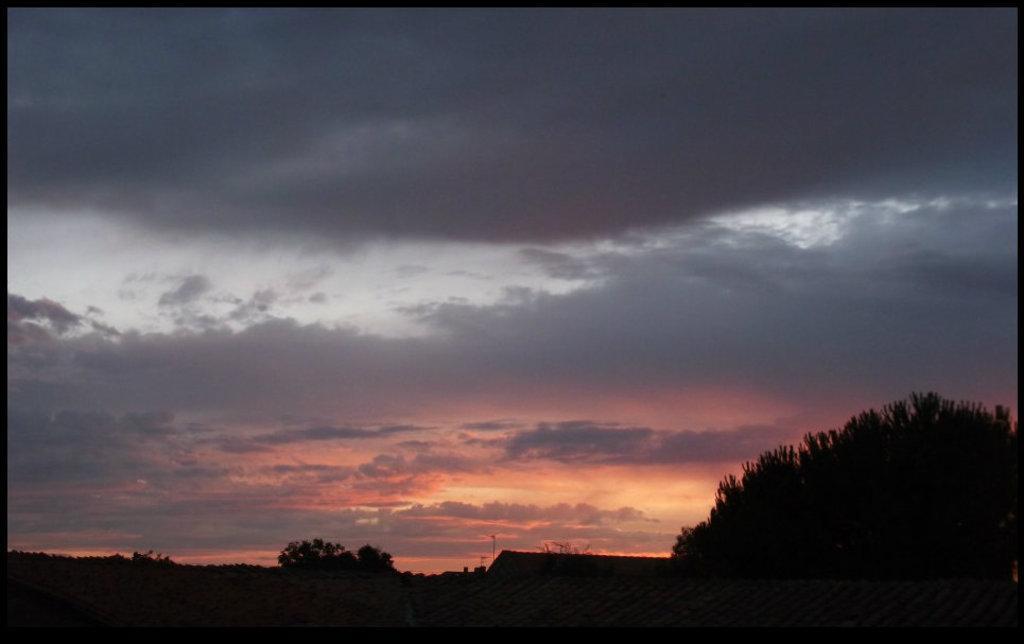In one or two sentences, can you explain what this image depicts? In this picture we can see a few trees. Sky is cloudy. 